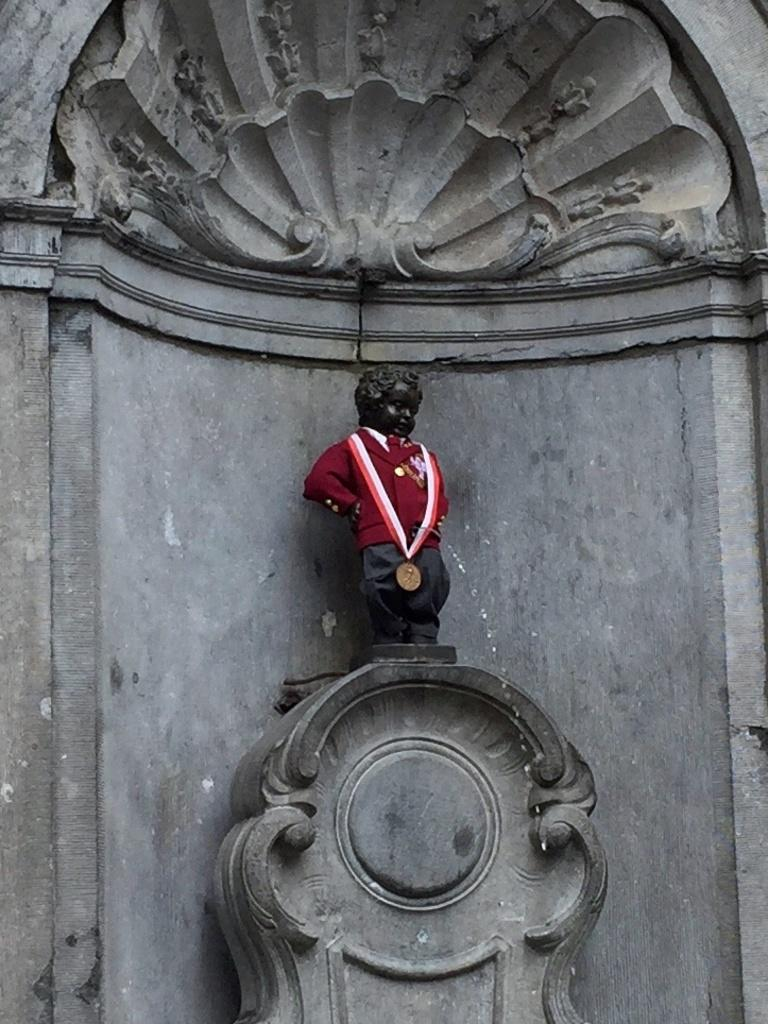What is the main subject in the image? There is a statue in the image. What can be said about the statue's color? The statue is black in color. What is the statue wearing? The statue is wearing a red and black colored dress. What other type of sculpture can be seen in the image? There is a rock sculpture in the image. What is the color of the rock sculpture? The rock sculpture is ash in color. What type of card game is being played in the image? There is no card game present in the image; it features a statue and a rock sculpture. What is the statue's mental state in the image? The statue is an inanimate object and does not have a mental state. 